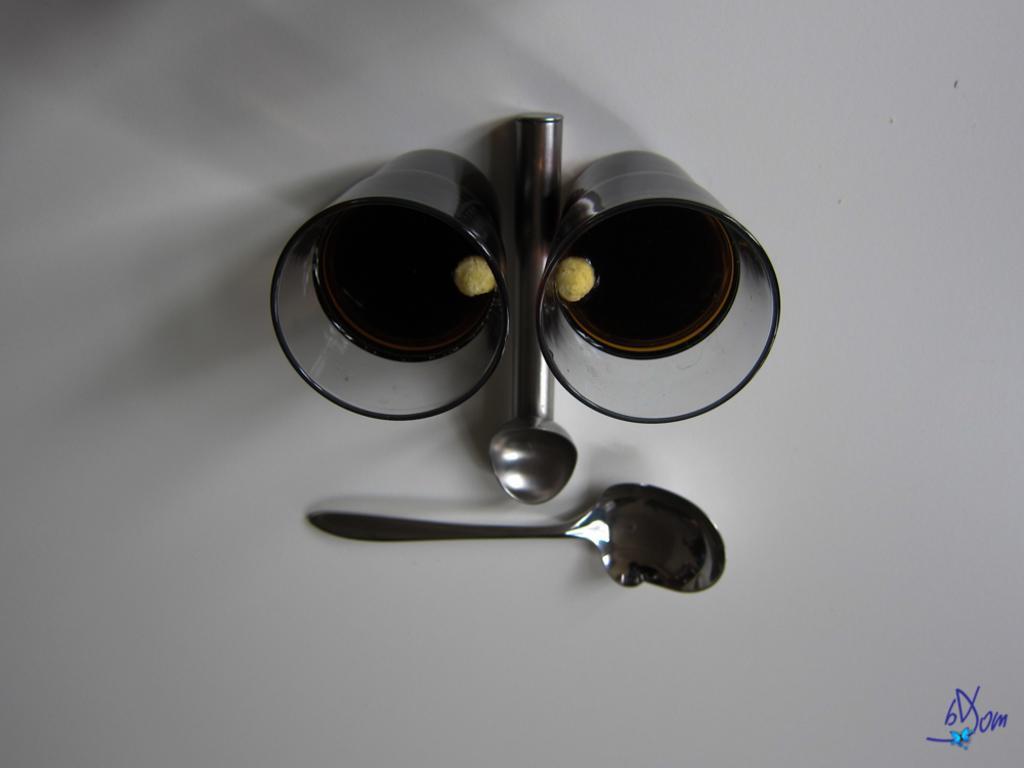Please provide a concise description of this image. In this image we can see two glasses with drink and two spoons on a surface. 